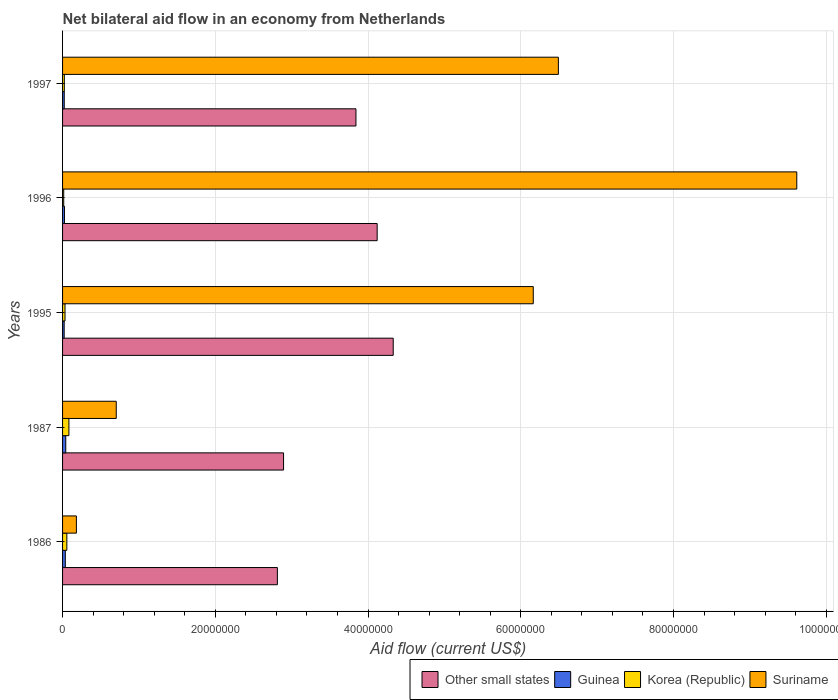How many different coloured bars are there?
Offer a very short reply. 4. How many bars are there on the 1st tick from the bottom?
Provide a succinct answer. 4. In how many cases, is the number of bars for a given year not equal to the number of legend labels?
Provide a succinct answer. 0. What is the net bilateral aid flow in Suriname in 1987?
Your answer should be very brief. 7.03e+06. Across all years, what is the maximum net bilateral aid flow in Suriname?
Provide a succinct answer. 9.62e+07. Across all years, what is the minimum net bilateral aid flow in Suriname?
Give a very brief answer. 1.81e+06. What is the total net bilateral aid flow in Korea (Republic) in the graph?
Make the answer very short. 2.09e+06. What is the difference between the net bilateral aid flow in Suriname in 1986 and that in 1997?
Offer a very short reply. -6.31e+07. What is the difference between the net bilateral aid flow in Guinea in 1987 and the net bilateral aid flow in Suriname in 1995?
Offer a very short reply. -6.12e+07. What is the average net bilateral aid flow in Other small states per year?
Ensure brevity in your answer.  3.60e+07. In the year 1997, what is the difference between the net bilateral aid flow in Suriname and net bilateral aid flow in Guinea?
Offer a terse response. 6.47e+07. In how many years, is the net bilateral aid flow in Other small states greater than 80000000 US$?
Your answer should be very brief. 0. What is the ratio of the net bilateral aid flow in Suriname in 1996 to that in 1997?
Offer a terse response. 1.48. Is the difference between the net bilateral aid flow in Suriname in 1995 and 1997 greater than the difference between the net bilateral aid flow in Guinea in 1995 and 1997?
Offer a very short reply. No. What is the difference between the highest and the lowest net bilateral aid flow in Korea (Republic)?
Make the answer very short. 6.80e+05. Is the sum of the net bilateral aid flow in Korea (Republic) in 1986 and 1996 greater than the maximum net bilateral aid flow in Guinea across all years?
Ensure brevity in your answer.  Yes. Is it the case that in every year, the sum of the net bilateral aid flow in Other small states and net bilateral aid flow in Guinea is greater than the sum of net bilateral aid flow in Suriname and net bilateral aid flow in Korea (Republic)?
Give a very brief answer. Yes. What does the 1st bar from the top in 1995 represents?
Provide a short and direct response. Suriname. What does the 1st bar from the bottom in 1995 represents?
Make the answer very short. Other small states. How many bars are there?
Provide a succinct answer. 20. What is the difference between two consecutive major ticks on the X-axis?
Your answer should be very brief. 2.00e+07. Are the values on the major ticks of X-axis written in scientific E-notation?
Give a very brief answer. No. Where does the legend appear in the graph?
Your answer should be compact. Bottom right. How many legend labels are there?
Your response must be concise. 4. How are the legend labels stacked?
Offer a terse response. Horizontal. What is the title of the graph?
Your response must be concise. Net bilateral aid flow in an economy from Netherlands. What is the Aid flow (current US$) in Other small states in 1986?
Provide a short and direct response. 2.81e+07. What is the Aid flow (current US$) of Korea (Republic) in 1986?
Make the answer very short. 5.60e+05. What is the Aid flow (current US$) of Suriname in 1986?
Provide a short and direct response. 1.81e+06. What is the Aid flow (current US$) of Other small states in 1987?
Give a very brief answer. 2.89e+07. What is the Aid flow (current US$) of Korea (Republic) in 1987?
Ensure brevity in your answer.  8.30e+05. What is the Aid flow (current US$) of Suriname in 1987?
Provide a succinct answer. 7.03e+06. What is the Aid flow (current US$) in Other small states in 1995?
Give a very brief answer. 4.33e+07. What is the Aid flow (current US$) in Guinea in 1995?
Offer a very short reply. 2.10e+05. What is the Aid flow (current US$) in Suriname in 1995?
Your answer should be compact. 6.16e+07. What is the Aid flow (current US$) in Other small states in 1996?
Give a very brief answer. 4.12e+07. What is the Aid flow (current US$) in Guinea in 1996?
Provide a short and direct response. 2.50e+05. What is the Aid flow (current US$) in Suriname in 1996?
Provide a succinct answer. 9.62e+07. What is the Aid flow (current US$) in Other small states in 1997?
Your answer should be compact. 3.84e+07. What is the Aid flow (current US$) in Guinea in 1997?
Keep it short and to the point. 2.20e+05. What is the Aid flow (current US$) in Korea (Republic) in 1997?
Provide a short and direct response. 2.30e+05. What is the Aid flow (current US$) of Suriname in 1997?
Provide a succinct answer. 6.49e+07. Across all years, what is the maximum Aid flow (current US$) of Other small states?
Offer a terse response. 4.33e+07. Across all years, what is the maximum Aid flow (current US$) in Korea (Republic)?
Keep it short and to the point. 8.30e+05. Across all years, what is the maximum Aid flow (current US$) of Suriname?
Make the answer very short. 9.62e+07. Across all years, what is the minimum Aid flow (current US$) in Other small states?
Ensure brevity in your answer.  2.81e+07. Across all years, what is the minimum Aid flow (current US$) of Suriname?
Make the answer very short. 1.81e+06. What is the total Aid flow (current US$) in Other small states in the graph?
Make the answer very short. 1.80e+08. What is the total Aid flow (current US$) in Guinea in the graph?
Ensure brevity in your answer.  1.46e+06. What is the total Aid flow (current US$) in Korea (Republic) in the graph?
Offer a terse response. 2.09e+06. What is the total Aid flow (current US$) of Suriname in the graph?
Provide a succinct answer. 2.32e+08. What is the difference between the Aid flow (current US$) of Other small states in 1986 and that in 1987?
Keep it short and to the point. -8.10e+05. What is the difference between the Aid flow (current US$) in Suriname in 1986 and that in 1987?
Provide a succinct answer. -5.22e+06. What is the difference between the Aid flow (current US$) in Other small states in 1986 and that in 1995?
Make the answer very short. -1.52e+07. What is the difference between the Aid flow (current US$) of Guinea in 1986 and that in 1995?
Your answer should be very brief. 1.50e+05. What is the difference between the Aid flow (current US$) in Suriname in 1986 and that in 1995?
Ensure brevity in your answer.  -5.98e+07. What is the difference between the Aid flow (current US$) of Other small states in 1986 and that in 1996?
Your answer should be very brief. -1.31e+07. What is the difference between the Aid flow (current US$) of Suriname in 1986 and that in 1996?
Provide a short and direct response. -9.43e+07. What is the difference between the Aid flow (current US$) of Other small states in 1986 and that in 1997?
Keep it short and to the point. -1.03e+07. What is the difference between the Aid flow (current US$) of Guinea in 1986 and that in 1997?
Provide a succinct answer. 1.40e+05. What is the difference between the Aid flow (current US$) of Korea (Republic) in 1986 and that in 1997?
Provide a succinct answer. 3.30e+05. What is the difference between the Aid flow (current US$) in Suriname in 1986 and that in 1997?
Ensure brevity in your answer.  -6.31e+07. What is the difference between the Aid flow (current US$) in Other small states in 1987 and that in 1995?
Your answer should be very brief. -1.44e+07. What is the difference between the Aid flow (current US$) of Guinea in 1987 and that in 1995?
Provide a short and direct response. 2.10e+05. What is the difference between the Aid flow (current US$) in Korea (Republic) in 1987 and that in 1995?
Offer a very short reply. 5.10e+05. What is the difference between the Aid flow (current US$) in Suriname in 1987 and that in 1995?
Your response must be concise. -5.46e+07. What is the difference between the Aid flow (current US$) of Other small states in 1987 and that in 1996?
Offer a terse response. -1.23e+07. What is the difference between the Aid flow (current US$) of Korea (Republic) in 1987 and that in 1996?
Offer a terse response. 6.80e+05. What is the difference between the Aid flow (current US$) of Suriname in 1987 and that in 1996?
Offer a terse response. -8.91e+07. What is the difference between the Aid flow (current US$) in Other small states in 1987 and that in 1997?
Offer a very short reply. -9.48e+06. What is the difference between the Aid flow (current US$) of Suriname in 1987 and that in 1997?
Ensure brevity in your answer.  -5.79e+07. What is the difference between the Aid flow (current US$) in Other small states in 1995 and that in 1996?
Keep it short and to the point. 2.10e+06. What is the difference between the Aid flow (current US$) in Korea (Republic) in 1995 and that in 1996?
Give a very brief answer. 1.70e+05. What is the difference between the Aid flow (current US$) of Suriname in 1995 and that in 1996?
Keep it short and to the point. -3.45e+07. What is the difference between the Aid flow (current US$) in Other small states in 1995 and that in 1997?
Ensure brevity in your answer.  4.88e+06. What is the difference between the Aid flow (current US$) of Guinea in 1995 and that in 1997?
Provide a short and direct response. -10000. What is the difference between the Aid flow (current US$) of Korea (Republic) in 1995 and that in 1997?
Your answer should be very brief. 9.00e+04. What is the difference between the Aid flow (current US$) of Suriname in 1995 and that in 1997?
Offer a very short reply. -3.29e+06. What is the difference between the Aid flow (current US$) in Other small states in 1996 and that in 1997?
Keep it short and to the point. 2.78e+06. What is the difference between the Aid flow (current US$) in Guinea in 1996 and that in 1997?
Make the answer very short. 3.00e+04. What is the difference between the Aid flow (current US$) in Korea (Republic) in 1996 and that in 1997?
Provide a succinct answer. -8.00e+04. What is the difference between the Aid flow (current US$) of Suriname in 1996 and that in 1997?
Your answer should be compact. 3.12e+07. What is the difference between the Aid flow (current US$) of Other small states in 1986 and the Aid flow (current US$) of Guinea in 1987?
Offer a terse response. 2.77e+07. What is the difference between the Aid flow (current US$) in Other small states in 1986 and the Aid flow (current US$) in Korea (Republic) in 1987?
Your answer should be very brief. 2.73e+07. What is the difference between the Aid flow (current US$) in Other small states in 1986 and the Aid flow (current US$) in Suriname in 1987?
Give a very brief answer. 2.11e+07. What is the difference between the Aid flow (current US$) in Guinea in 1986 and the Aid flow (current US$) in Korea (Republic) in 1987?
Give a very brief answer. -4.70e+05. What is the difference between the Aid flow (current US$) in Guinea in 1986 and the Aid flow (current US$) in Suriname in 1987?
Your response must be concise. -6.67e+06. What is the difference between the Aid flow (current US$) in Korea (Republic) in 1986 and the Aid flow (current US$) in Suriname in 1987?
Provide a succinct answer. -6.47e+06. What is the difference between the Aid flow (current US$) of Other small states in 1986 and the Aid flow (current US$) of Guinea in 1995?
Ensure brevity in your answer.  2.79e+07. What is the difference between the Aid flow (current US$) in Other small states in 1986 and the Aid flow (current US$) in Korea (Republic) in 1995?
Make the answer very short. 2.78e+07. What is the difference between the Aid flow (current US$) in Other small states in 1986 and the Aid flow (current US$) in Suriname in 1995?
Offer a terse response. -3.35e+07. What is the difference between the Aid flow (current US$) of Guinea in 1986 and the Aid flow (current US$) of Suriname in 1995?
Provide a succinct answer. -6.13e+07. What is the difference between the Aid flow (current US$) of Korea (Republic) in 1986 and the Aid flow (current US$) of Suriname in 1995?
Your answer should be compact. -6.11e+07. What is the difference between the Aid flow (current US$) of Other small states in 1986 and the Aid flow (current US$) of Guinea in 1996?
Offer a terse response. 2.79e+07. What is the difference between the Aid flow (current US$) in Other small states in 1986 and the Aid flow (current US$) in Korea (Republic) in 1996?
Keep it short and to the point. 2.80e+07. What is the difference between the Aid flow (current US$) of Other small states in 1986 and the Aid flow (current US$) of Suriname in 1996?
Keep it short and to the point. -6.80e+07. What is the difference between the Aid flow (current US$) of Guinea in 1986 and the Aid flow (current US$) of Suriname in 1996?
Your answer should be very brief. -9.58e+07. What is the difference between the Aid flow (current US$) in Korea (Republic) in 1986 and the Aid flow (current US$) in Suriname in 1996?
Give a very brief answer. -9.56e+07. What is the difference between the Aid flow (current US$) of Other small states in 1986 and the Aid flow (current US$) of Guinea in 1997?
Keep it short and to the point. 2.79e+07. What is the difference between the Aid flow (current US$) in Other small states in 1986 and the Aid flow (current US$) in Korea (Republic) in 1997?
Ensure brevity in your answer.  2.79e+07. What is the difference between the Aid flow (current US$) in Other small states in 1986 and the Aid flow (current US$) in Suriname in 1997?
Give a very brief answer. -3.68e+07. What is the difference between the Aid flow (current US$) in Guinea in 1986 and the Aid flow (current US$) in Suriname in 1997?
Offer a very short reply. -6.46e+07. What is the difference between the Aid flow (current US$) of Korea (Republic) in 1986 and the Aid flow (current US$) of Suriname in 1997?
Your answer should be compact. -6.44e+07. What is the difference between the Aid flow (current US$) in Other small states in 1987 and the Aid flow (current US$) in Guinea in 1995?
Ensure brevity in your answer.  2.87e+07. What is the difference between the Aid flow (current US$) of Other small states in 1987 and the Aid flow (current US$) of Korea (Republic) in 1995?
Provide a short and direct response. 2.86e+07. What is the difference between the Aid flow (current US$) of Other small states in 1987 and the Aid flow (current US$) of Suriname in 1995?
Your answer should be compact. -3.27e+07. What is the difference between the Aid flow (current US$) of Guinea in 1987 and the Aid flow (current US$) of Suriname in 1995?
Offer a terse response. -6.12e+07. What is the difference between the Aid flow (current US$) in Korea (Republic) in 1987 and the Aid flow (current US$) in Suriname in 1995?
Provide a succinct answer. -6.08e+07. What is the difference between the Aid flow (current US$) of Other small states in 1987 and the Aid flow (current US$) of Guinea in 1996?
Keep it short and to the point. 2.87e+07. What is the difference between the Aid flow (current US$) of Other small states in 1987 and the Aid flow (current US$) of Korea (Republic) in 1996?
Offer a very short reply. 2.88e+07. What is the difference between the Aid flow (current US$) in Other small states in 1987 and the Aid flow (current US$) in Suriname in 1996?
Ensure brevity in your answer.  -6.72e+07. What is the difference between the Aid flow (current US$) of Guinea in 1987 and the Aid flow (current US$) of Suriname in 1996?
Make the answer very short. -9.57e+07. What is the difference between the Aid flow (current US$) of Korea (Republic) in 1987 and the Aid flow (current US$) of Suriname in 1996?
Ensure brevity in your answer.  -9.53e+07. What is the difference between the Aid flow (current US$) in Other small states in 1987 and the Aid flow (current US$) in Guinea in 1997?
Your answer should be very brief. 2.87e+07. What is the difference between the Aid flow (current US$) in Other small states in 1987 and the Aid flow (current US$) in Korea (Republic) in 1997?
Ensure brevity in your answer.  2.87e+07. What is the difference between the Aid flow (current US$) in Other small states in 1987 and the Aid flow (current US$) in Suriname in 1997?
Your answer should be compact. -3.60e+07. What is the difference between the Aid flow (current US$) of Guinea in 1987 and the Aid flow (current US$) of Korea (Republic) in 1997?
Your answer should be very brief. 1.90e+05. What is the difference between the Aid flow (current US$) of Guinea in 1987 and the Aid flow (current US$) of Suriname in 1997?
Provide a short and direct response. -6.45e+07. What is the difference between the Aid flow (current US$) in Korea (Republic) in 1987 and the Aid flow (current US$) in Suriname in 1997?
Keep it short and to the point. -6.41e+07. What is the difference between the Aid flow (current US$) of Other small states in 1995 and the Aid flow (current US$) of Guinea in 1996?
Keep it short and to the point. 4.30e+07. What is the difference between the Aid flow (current US$) of Other small states in 1995 and the Aid flow (current US$) of Korea (Republic) in 1996?
Ensure brevity in your answer.  4.32e+07. What is the difference between the Aid flow (current US$) in Other small states in 1995 and the Aid flow (current US$) in Suriname in 1996?
Offer a terse response. -5.28e+07. What is the difference between the Aid flow (current US$) of Guinea in 1995 and the Aid flow (current US$) of Korea (Republic) in 1996?
Offer a very short reply. 6.00e+04. What is the difference between the Aid flow (current US$) in Guinea in 1995 and the Aid flow (current US$) in Suriname in 1996?
Offer a terse response. -9.59e+07. What is the difference between the Aid flow (current US$) in Korea (Republic) in 1995 and the Aid flow (current US$) in Suriname in 1996?
Give a very brief answer. -9.58e+07. What is the difference between the Aid flow (current US$) of Other small states in 1995 and the Aid flow (current US$) of Guinea in 1997?
Your response must be concise. 4.31e+07. What is the difference between the Aid flow (current US$) in Other small states in 1995 and the Aid flow (current US$) in Korea (Republic) in 1997?
Your answer should be very brief. 4.31e+07. What is the difference between the Aid flow (current US$) in Other small states in 1995 and the Aid flow (current US$) in Suriname in 1997?
Keep it short and to the point. -2.16e+07. What is the difference between the Aid flow (current US$) of Guinea in 1995 and the Aid flow (current US$) of Korea (Republic) in 1997?
Give a very brief answer. -2.00e+04. What is the difference between the Aid flow (current US$) of Guinea in 1995 and the Aid flow (current US$) of Suriname in 1997?
Offer a terse response. -6.47e+07. What is the difference between the Aid flow (current US$) of Korea (Republic) in 1995 and the Aid flow (current US$) of Suriname in 1997?
Offer a very short reply. -6.46e+07. What is the difference between the Aid flow (current US$) in Other small states in 1996 and the Aid flow (current US$) in Guinea in 1997?
Offer a terse response. 4.10e+07. What is the difference between the Aid flow (current US$) in Other small states in 1996 and the Aid flow (current US$) in Korea (Republic) in 1997?
Your response must be concise. 4.10e+07. What is the difference between the Aid flow (current US$) of Other small states in 1996 and the Aid flow (current US$) of Suriname in 1997?
Keep it short and to the point. -2.37e+07. What is the difference between the Aid flow (current US$) of Guinea in 1996 and the Aid flow (current US$) of Suriname in 1997?
Make the answer very short. -6.47e+07. What is the difference between the Aid flow (current US$) in Korea (Republic) in 1996 and the Aid flow (current US$) in Suriname in 1997?
Your answer should be very brief. -6.48e+07. What is the average Aid flow (current US$) of Other small states per year?
Provide a succinct answer. 3.60e+07. What is the average Aid flow (current US$) of Guinea per year?
Your response must be concise. 2.92e+05. What is the average Aid flow (current US$) in Korea (Republic) per year?
Your answer should be very brief. 4.18e+05. What is the average Aid flow (current US$) of Suriname per year?
Offer a terse response. 4.63e+07. In the year 1986, what is the difference between the Aid flow (current US$) of Other small states and Aid flow (current US$) of Guinea?
Give a very brief answer. 2.78e+07. In the year 1986, what is the difference between the Aid flow (current US$) of Other small states and Aid flow (current US$) of Korea (Republic)?
Offer a terse response. 2.76e+07. In the year 1986, what is the difference between the Aid flow (current US$) of Other small states and Aid flow (current US$) of Suriname?
Ensure brevity in your answer.  2.63e+07. In the year 1986, what is the difference between the Aid flow (current US$) in Guinea and Aid flow (current US$) in Korea (Republic)?
Your response must be concise. -2.00e+05. In the year 1986, what is the difference between the Aid flow (current US$) of Guinea and Aid flow (current US$) of Suriname?
Your response must be concise. -1.45e+06. In the year 1986, what is the difference between the Aid flow (current US$) in Korea (Republic) and Aid flow (current US$) in Suriname?
Give a very brief answer. -1.25e+06. In the year 1987, what is the difference between the Aid flow (current US$) of Other small states and Aid flow (current US$) of Guinea?
Give a very brief answer. 2.85e+07. In the year 1987, what is the difference between the Aid flow (current US$) in Other small states and Aid flow (current US$) in Korea (Republic)?
Offer a very short reply. 2.81e+07. In the year 1987, what is the difference between the Aid flow (current US$) of Other small states and Aid flow (current US$) of Suriname?
Your answer should be compact. 2.19e+07. In the year 1987, what is the difference between the Aid flow (current US$) in Guinea and Aid flow (current US$) in Korea (Republic)?
Provide a short and direct response. -4.10e+05. In the year 1987, what is the difference between the Aid flow (current US$) of Guinea and Aid flow (current US$) of Suriname?
Keep it short and to the point. -6.61e+06. In the year 1987, what is the difference between the Aid flow (current US$) in Korea (Republic) and Aid flow (current US$) in Suriname?
Give a very brief answer. -6.20e+06. In the year 1995, what is the difference between the Aid flow (current US$) in Other small states and Aid flow (current US$) in Guinea?
Make the answer very short. 4.31e+07. In the year 1995, what is the difference between the Aid flow (current US$) in Other small states and Aid flow (current US$) in Korea (Republic)?
Offer a very short reply. 4.30e+07. In the year 1995, what is the difference between the Aid flow (current US$) in Other small states and Aid flow (current US$) in Suriname?
Make the answer very short. -1.83e+07. In the year 1995, what is the difference between the Aid flow (current US$) in Guinea and Aid flow (current US$) in Korea (Republic)?
Your response must be concise. -1.10e+05. In the year 1995, what is the difference between the Aid flow (current US$) in Guinea and Aid flow (current US$) in Suriname?
Your response must be concise. -6.14e+07. In the year 1995, what is the difference between the Aid flow (current US$) of Korea (Republic) and Aid flow (current US$) of Suriname?
Give a very brief answer. -6.13e+07. In the year 1996, what is the difference between the Aid flow (current US$) in Other small states and Aid flow (current US$) in Guinea?
Give a very brief answer. 4.10e+07. In the year 1996, what is the difference between the Aid flow (current US$) in Other small states and Aid flow (current US$) in Korea (Republic)?
Your response must be concise. 4.10e+07. In the year 1996, what is the difference between the Aid flow (current US$) in Other small states and Aid flow (current US$) in Suriname?
Your answer should be very brief. -5.50e+07. In the year 1996, what is the difference between the Aid flow (current US$) in Guinea and Aid flow (current US$) in Korea (Republic)?
Your answer should be compact. 1.00e+05. In the year 1996, what is the difference between the Aid flow (current US$) in Guinea and Aid flow (current US$) in Suriname?
Keep it short and to the point. -9.59e+07. In the year 1996, what is the difference between the Aid flow (current US$) of Korea (Republic) and Aid flow (current US$) of Suriname?
Give a very brief answer. -9.60e+07. In the year 1997, what is the difference between the Aid flow (current US$) in Other small states and Aid flow (current US$) in Guinea?
Offer a terse response. 3.82e+07. In the year 1997, what is the difference between the Aid flow (current US$) in Other small states and Aid flow (current US$) in Korea (Republic)?
Your response must be concise. 3.82e+07. In the year 1997, what is the difference between the Aid flow (current US$) of Other small states and Aid flow (current US$) of Suriname?
Provide a succinct answer. -2.65e+07. In the year 1997, what is the difference between the Aid flow (current US$) of Guinea and Aid flow (current US$) of Korea (Republic)?
Offer a terse response. -10000. In the year 1997, what is the difference between the Aid flow (current US$) of Guinea and Aid flow (current US$) of Suriname?
Offer a very short reply. -6.47e+07. In the year 1997, what is the difference between the Aid flow (current US$) of Korea (Republic) and Aid flow (current US$) of Suriname?
Keep it short and to the point. -6.47e+07. What is the ratio of the Aid flow (current US$) of Korea (Republic) in 1986 to that in 1987?
Your answer should be compact. 0.67. What is the ratio of the Aid flow (current US$) of Suriname in 1986 to that in 1987?
Your answer should be very brief. 0.26. What is the ratio of the Aid flow (current US$) of Other small states in 1986 to that in 1995?
Offer a very short reply. 0.65. What is the ratio of the Aid flow (current US$) of Guinea in 1986 to that in 1995?
Give a very brief answer. 1.71. What is the ratio of the Aid flow (current US$) of Suriname in 1986 to that in 1995?
Offer a very short reply. 0.03. What is the ratio of the Aid flow (current US$) in Other small states in 1986 to that in 1996?
Your answer should be very brief. 0.68. What is the ratio of the Aid flow (current US$) in Guinea in 1986 to that in 1996?
Keep it short and to the point. 1.44. What is the ratio of the Aid flow (current US$) in Korea (Republic) in 1986 to that in 1996?
Offer a terse response. 3.73. What is the ratio of the Aid flow (current US$) of Suriname in 1986 to that in 1996?
Give a very brief answer. 0.02. What is the ratio of the Aid flow (current US$) of Other small states in 1986 to that in 1997?
Your response must be concise. 0.73. What is the ratio of the Aid flow (current US$) of Guinea in 1986 to that in 1997?
Offer a terse response. 1.64. What is the ratio of the Aid flow (current US$) in Korea (Republic) in 1986 to that in 1997?
Provide a succinct answer. 2.43. What is the ratio of the Aid flow (current US$) of Suriname in 1986 to that in 1997?
Your answer should be very brief. 0.03. What is the ratio of the Aid flow (current US$) of Other small states in 1987 to that in 1995?
Give a very brief answer. 0.67. What is the ratio of the Aid flow (current US$) of Guinea in 1987 to that in 1995?
Your answer should be compact. 2. What is the ratio of the Aid flow (current US$) in Korea (Republic) in 1987 to that in 1995?
Offer a very short reply. 2.59. What is the ratio of the Aid flow (current US$) in Suriname in 1987 to that in 1995?
Ensure brevity in your answer.  0.11. What is the ratio of the Aid flow (current US$) of Other small states in 1987 to that in 1996?
Make the answer very short. 0.7. What is the ratio of the Aid flow (current US$) in Guinea in 1987 to that in 1996?
Your answer should be compact. 1.68. What is the ratio of the Aid flow (current US$) of Korea (Republic) in 1987 to that in 1996?
Make the answer very short. 5.53. What is the ratio of the Aid flow (current US$) of Suriname in 1987 to that in 1996?
Provide a short and direct response. 0.07. What is the ratio of the Aid flow (current US$) in Other small states in 1987 to that in 1997?
Your answer should be very brief. 0.75. What is the ratio of the Aid flow (current US$) in Guinea in 1987 to that in 1997?
Provide a short and direct response. 1.91. What is the ratio of the Aid flow (current US$) in Korea (Republic) in 1987 to that in 1997?
Keep it short and to the point. 3.61. What is the ratio of the Aid flow (current US$) in Suriname in 1987 to that in 1997?
Your answer should be compact. 0.11. What is the ratio of the Aid flow (current US$) of Other small states in 1995 to that in 1996?
Make the answer very short. 1.05. What is the ratio of the Aid flow (current US$) of Guinea in 1995 to that in 1996?
Your response must be concise. 0.84. What is the ratio of the Aid flow (current US$) in Korea (Republic) in 1995 to that in 1996?
Your response must be concise. 2.13. What is the ratio of the Aid flow (current US$) in Suriname in 1995 to that in 1996?
Ensure brevity in your answer.  0.64. What is the ratio of the Aid flow (current US$) of Other small states in 1995 to that in 1997?
Ensure brevity in your answer.  1.13. What is the ratio of the Aid flow (current US$) of Guinea in 1995 to that in 1997?
Provide a short and direct response. 0.95. What is the ratio of the Aid flow (current US$) of Korea (Republic) in 1995 to that in 1997?
Provide a short and direct response. 1.39. What is the ratio of the Aid flow (current US$) in Suriname in 1995 to that in 1997?
Keep it short and to the point. 0.95. What is the ratio of the Aid flow (current US$) in Other small states in 1996 to that in 1997?
Offer a very short reply. 1.07. What is the ratio of the Aid flow (current US$) of Guinea in 1996 to that in 1997?
Provide a succinct answer. 1.14. What is the ratio of the Aid flow (current US$) of Korea (Republic) in 1996 to that in 1997?
Give a very brief answer. 0.65. What is the ratio of the Aid flow (current US$) of Suriname in 1996 to that in 1997?
Make the answer very short. 1.48. What is the difference between the highest and the second highest Aid flow (current US$) in Other small states?
Your answer should be compact. 2.10e+06. What is the difference between the highest and the second highest Aid flow (current US$) of Guinea?
Provide a succinct answer. 6.00e+04. What is the difference between the highest and the second highest Aid flow (current US$) of Korea (Republic)?
Offer a very short reply. 2.70e+05. What is the difference between the highest and the second highest Aid flow (current US$) in Suriname?
Your answer should be compact. 3.12e+07. What is the difference between the highest and the lowest Aid flow (current US$) in Other small states?
Your answer should be compact. 1.52e+07. What is the difference between the highest and the lowest Aid flow (current US$) of Korea (Republic)?
Give a very brief answer. 6.80e+05. What is the difference between the highest and the lowest Aid flow (current US$) in Suriname?
Your answer should be very brief. 9.43e+07. 